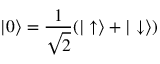<formula> <loc_0><loc_0><loc_500><loc_500>| 0 \rangle = \frac { 1 } { \sqrt { 2 } } ( | \uparrow \rangle + | \downarrow \rangle )</formula> 